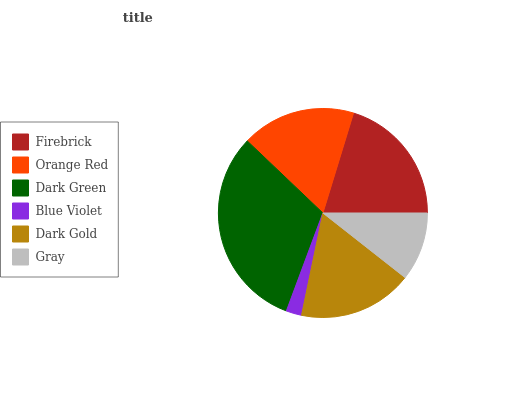Is Blue Violet the minimum?
Answer yes or no. Yes. Is Dark Green the maximum?
Answer yes or no. Yes. Is Orange Red the minimum?
Answer yes or no. No. Is Orange Red the maximum?
Answer yes or no. No. Is Firebrick greater than Orange Red?
Answer yes or no. Yes. Is Orange Red less than Firebrick?
Answer yes or no. Yes. Is Orange Red greater than Firebrick?
Answer yes or no. No. Is Firebrick less than Orange Red?
Answer yes or no. No. Is Dark Gold the high median?
Answer yes or no. Yes. Is Orange Red the low median?
Answer yes or no. Yes. Is Blue Violet the high median?
Answer yes or no. No. Is Firebrick the low median?
Answer yes or no. No. 